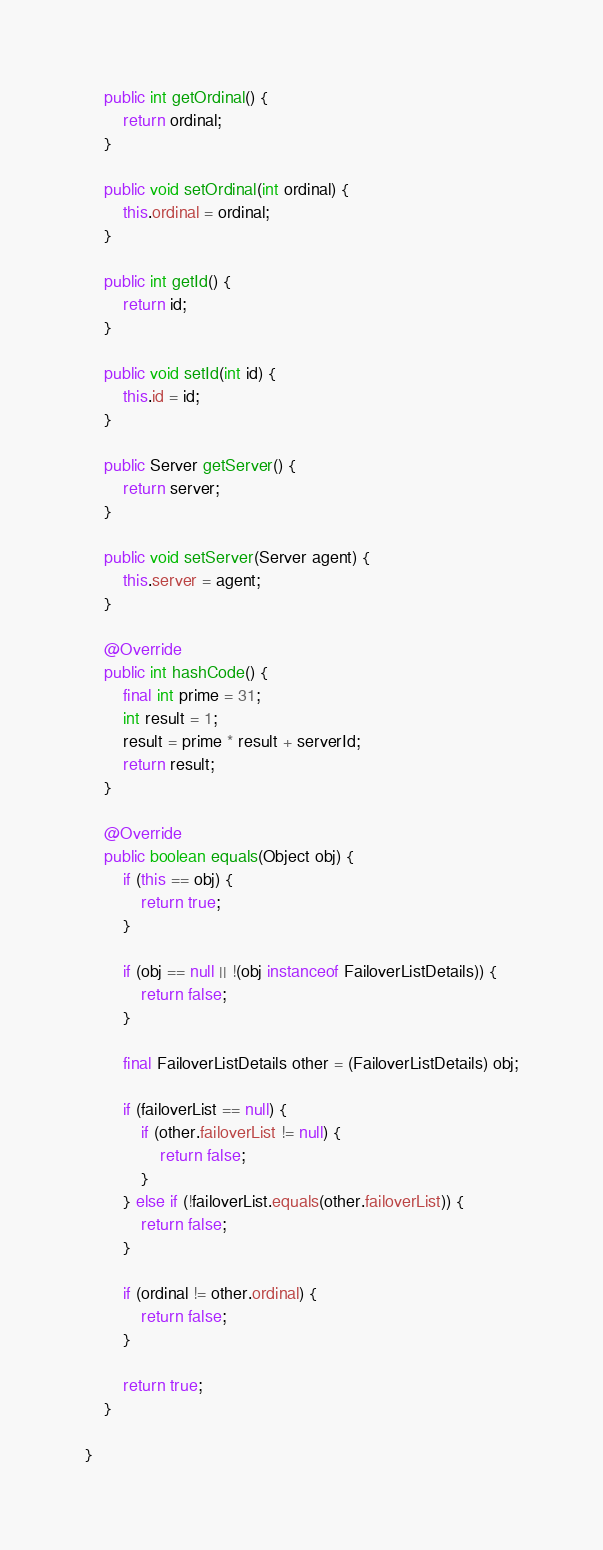<code> <loc_0><loc_0><loc_500><loc_500><_Java_>    public int getOrdinal() {
        return ordinal;
    }

    public void setOrdinal(int ordinal) {
        this.ordinal = ordinal;
    }

    public int getId() {
        return id;
    }

    public void setId(int id) {
        this.id = id;
    }

    public Server getServer() {
        return server;
    }

    public void setServer(Server agent) {
        this.server = agent;
    }

    @Override
    public int hashCode() {
        final int prime = 31;
        int result = 1;
        result = prime * result + serverId;
        return result;
    }

    @Override
    public boolean equals(Object obj) {
        if (this == obj) {
            return true;
        }

        if (obj == null || !(obj instanceof FailoverListDetails)) {
            return false;
        }

        final FailoverListDetails other = (FailoverListDetails) obj;

        if (failoverList == null) {
            if (other.failoverList != null) {
                return false;
            }
        } else if (!failoverList.equals(other.failoverList)) {
            return false;
        }

        if (ordinal != other.ordinal) {
            return false;
        }

        return true;
    }

}
</code> 